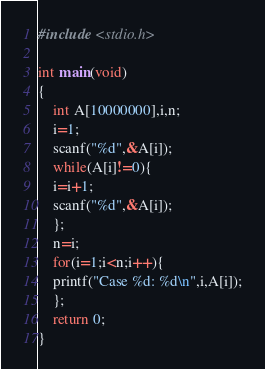Convert code to text. <code><loc_0><loc_0><loc_500><loc_500><_C_>#include <stdio.h>

int main(void)
{
	int A[10000000],i,n;
	i=1;
	scanf("%d",&A[i]);
	while(A[i]!=0){
	i=i+1;
	scanf("%d",&A[i]);
	};
	n=i;
	for(i=1;i<n;i++){
	printf("Case %d: %d\n",i,A[i]);
	};
	return 0;
}</code> 